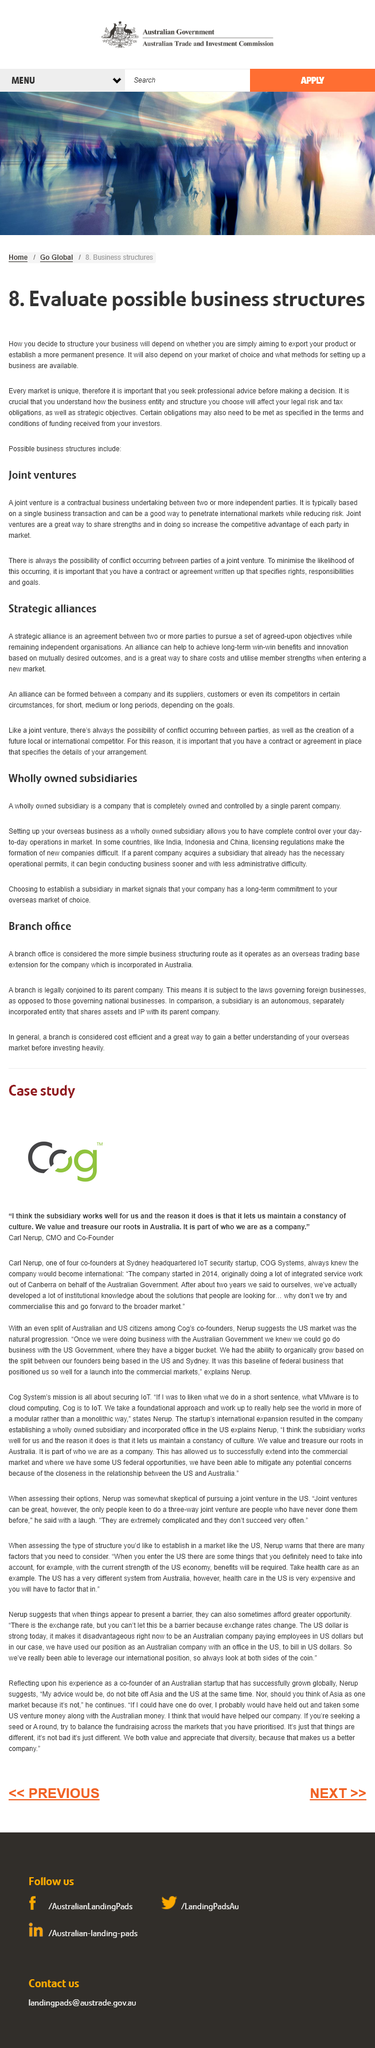Point out several critical features in this image. A subsidiary is the larger investment compared to a branch office. A joint venture is a business partnership formed by two or more independent parties through a contractual agreement, where they work together towards a common goal. A subsidiary is a more complex organizational structure than a branch office. Yes, there is always the possibility of conflict occurring between parties in an alliance. Branch offices are subject to the laws of the parent company, rather than those of the location in which they are physically located. 